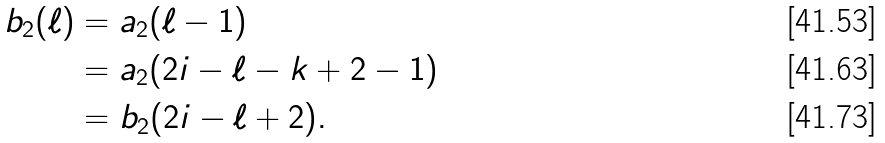<formula> <loc_0><loc_0><loc_500><loc_500>b _ { 2 } ( \ell ) & = a _ { 2 } ( \ell - 1 ) \\ & = a _ { 2 } ( 2 i - \ell - k + 2 - 1 ) \\ & = b _ { 2 } ( 2 i - \ell + 2 ) .</formula> 